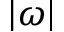<formula> <loc_0><loc_0><loc_500><loc_500>| \omega |</formula> 